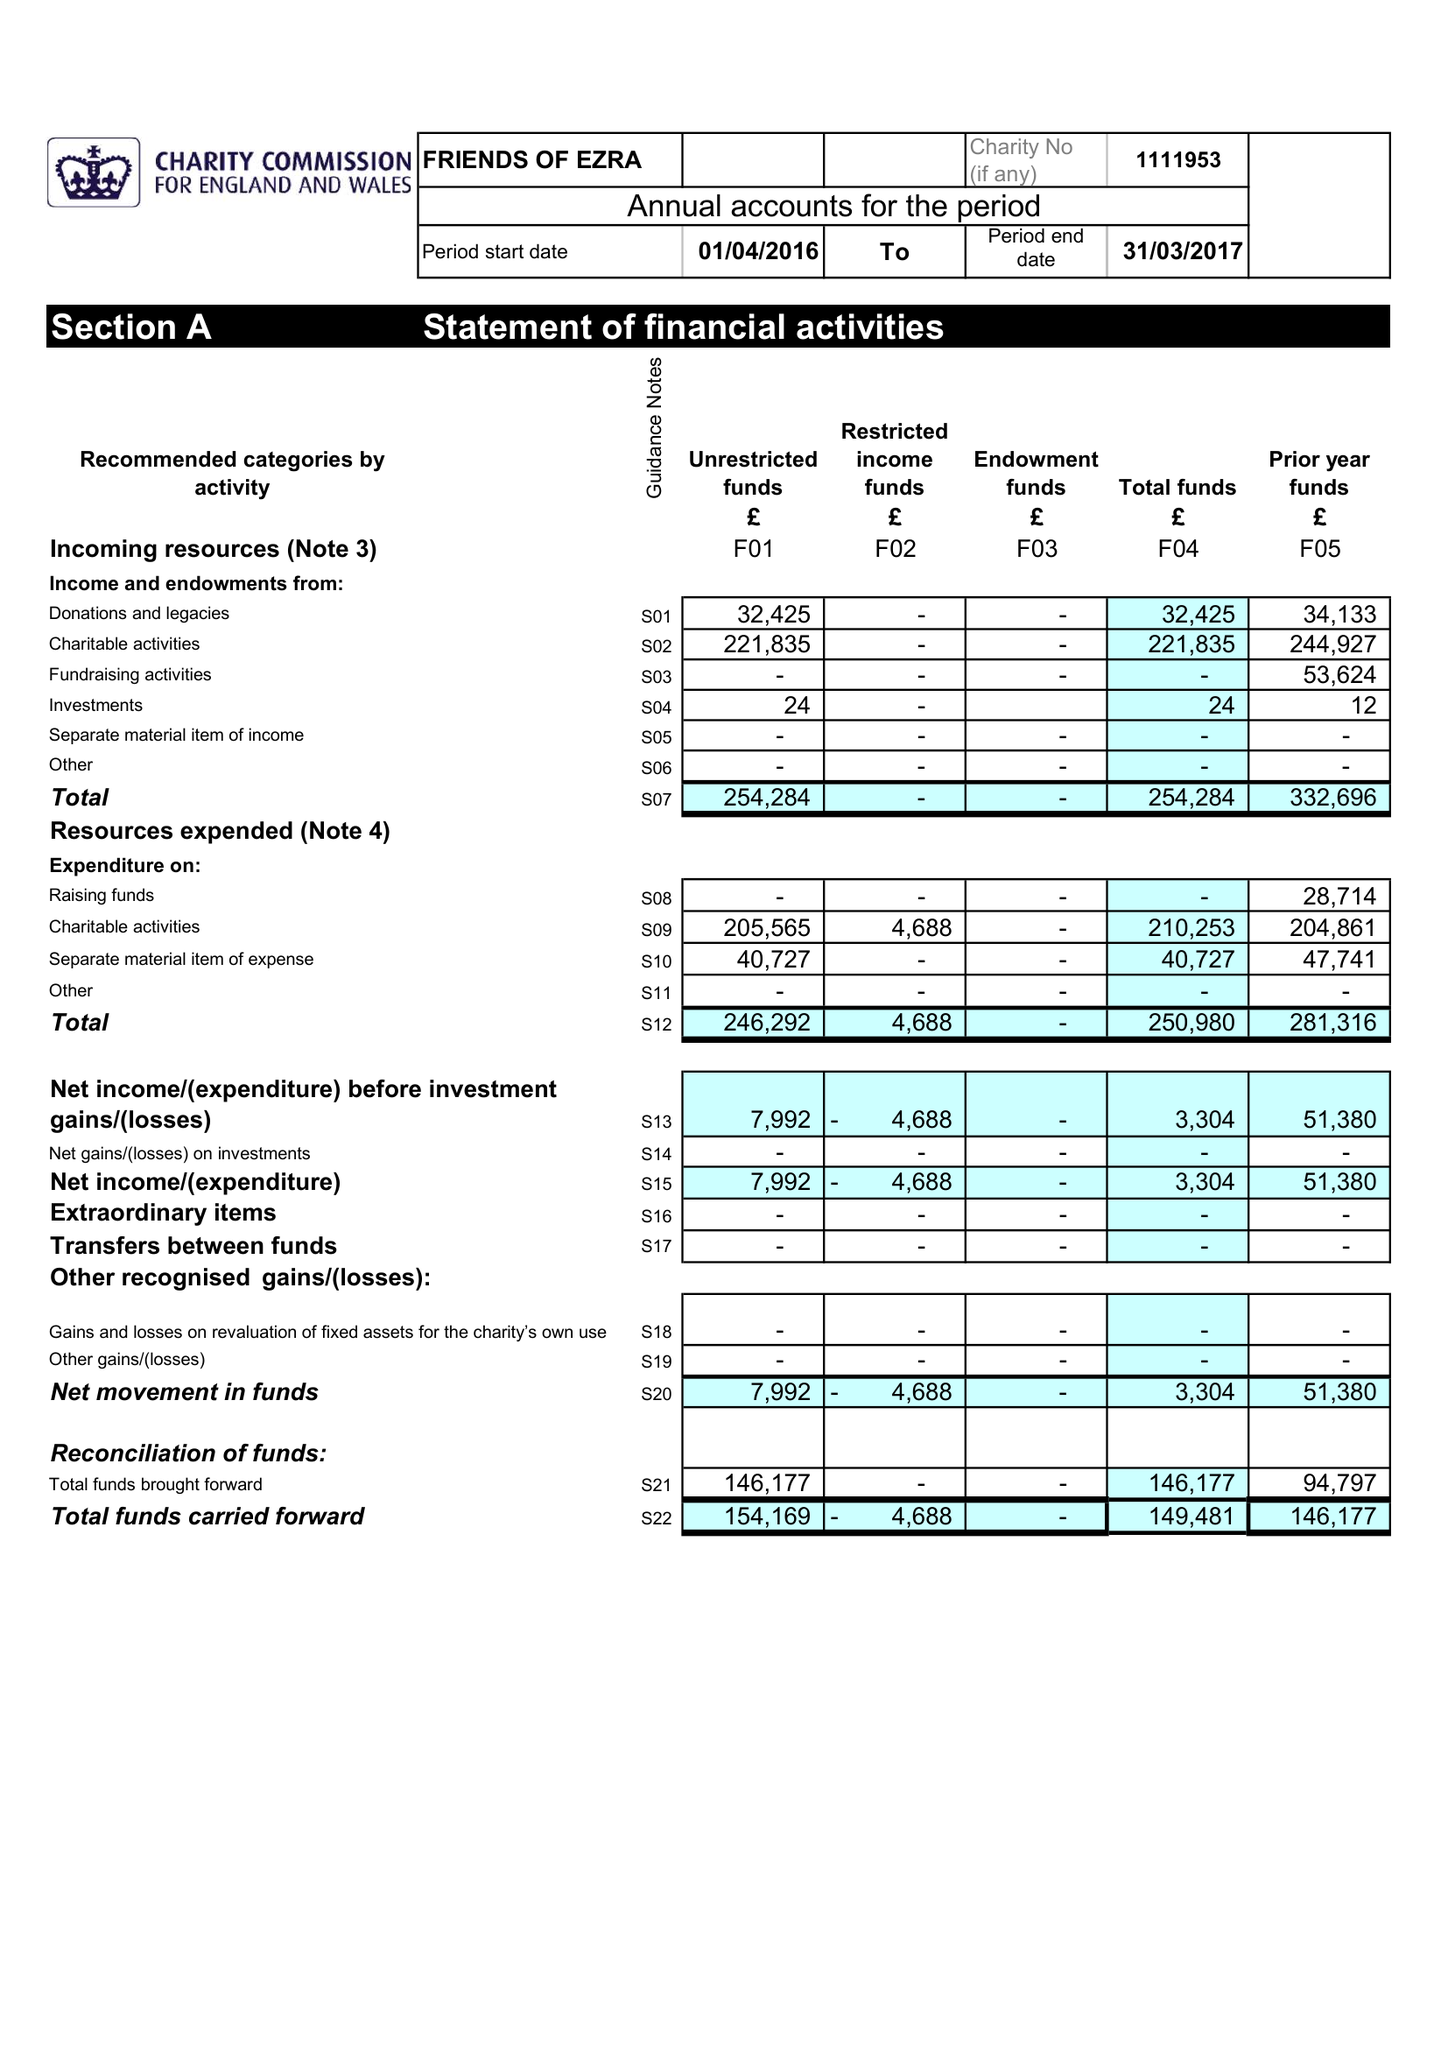What is the value for the income_annually_in_british_pounds?
Answer the question using a single word or phrase. 254284.00 